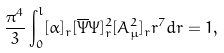<formula> <loc_0><loc_0><loc_500><loc_500>\frac { \pi ^ { 4 } } { 3 } \int _ { 0 } ^ { l } [ \alpha ] _ { r } [ \overline { \Psi } \Psi ] ^ { 2 } _ { r } [ A ^ { 2 } _ { \mu } ] _ { r } r ^ { 7 } d r = 1 ,</formula> 